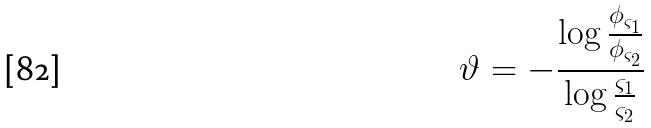Convert formula to latex. <formula><loc_0><loc_0><loc_500><loc_500>\vartheta = - \frac { \log \frac { \phi _ { \varsigma _ { 1 } } } { \phi _ { \varsigma _ { 2 } } } } { \log \frac { \varsigma _ { 1 } } { \varsigma _ { 2 } } }</formula> 